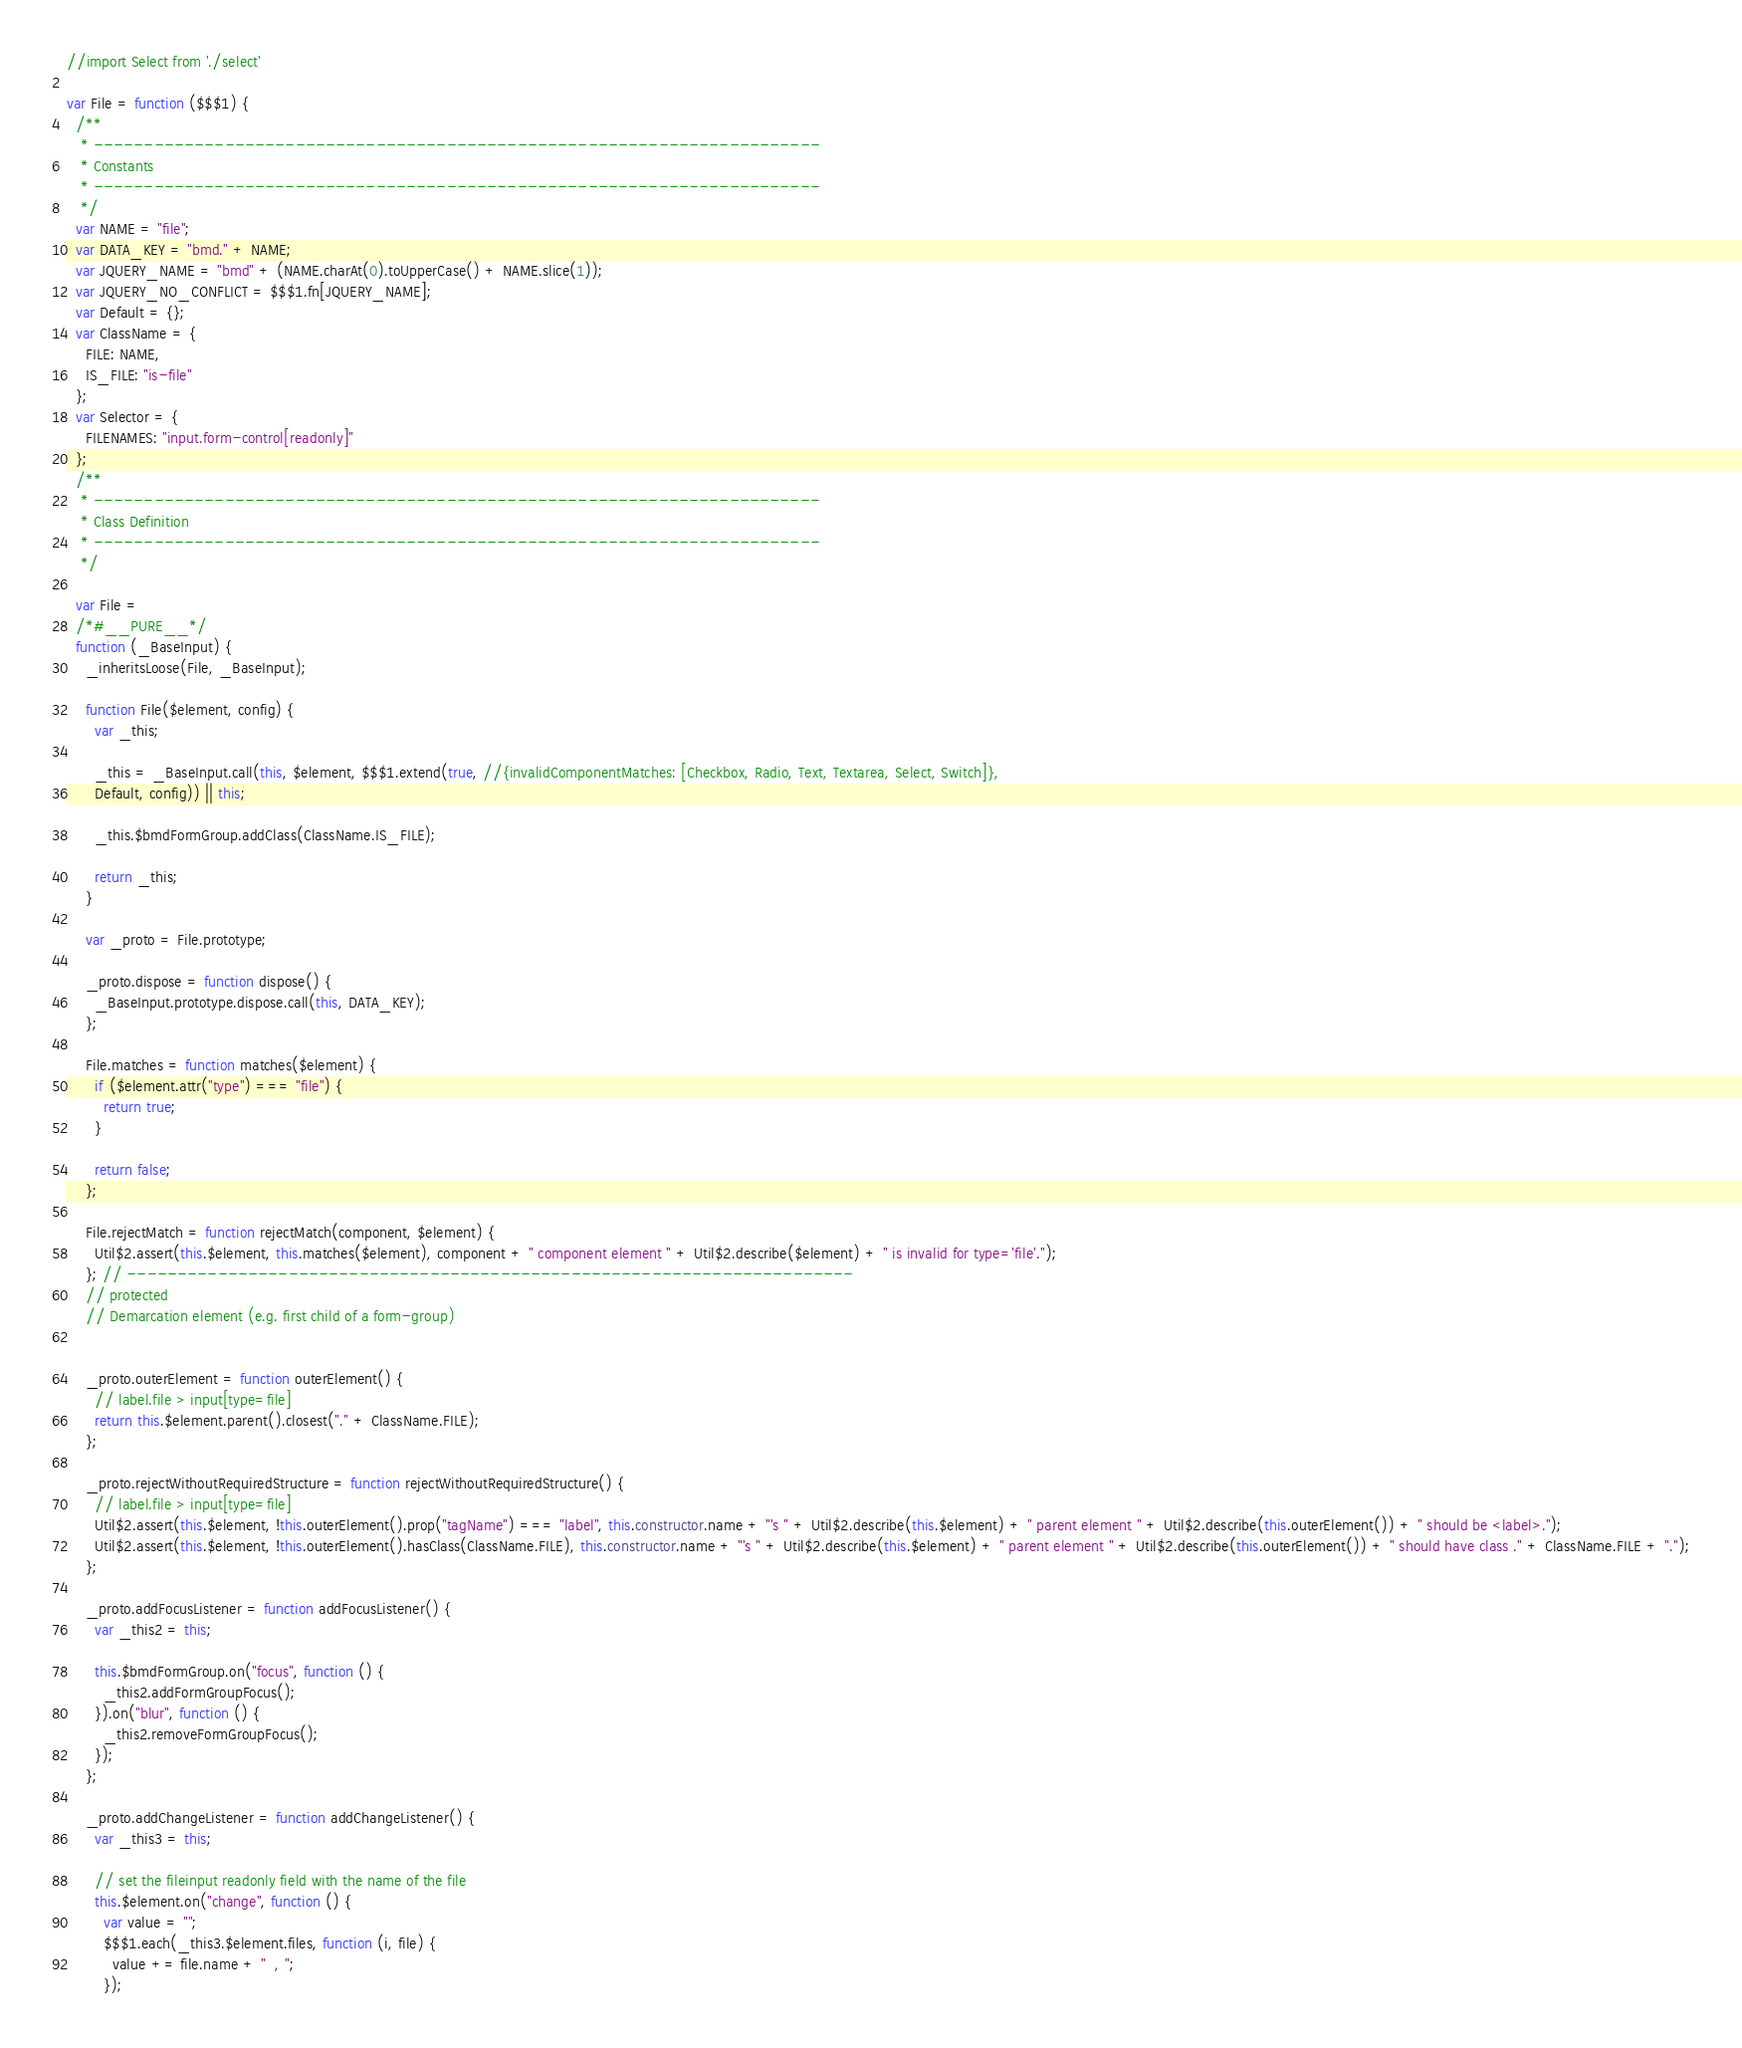<code> <loc_0><loc_0><loc_500><loc_500><_JavaScript_>//import Select from './select'

var File = function ($$$1) {
  /**
   * ------------------------------------------------------------------------
   * Constants
   * ------------------------------------------------------------------------
   */
  var NAME = "file";
  var DATA_KEY = "bmd." + NAME;
  var JQUERY_NAME = "bmd" + (NAME.charAt(0).toUpperCase() + NAME.slice(1));
  var JQUERY_NO_CONFLICT = $$$1.fn[JQUERY_NAME];
  var Default = {};
  var ClassName = {
    FILE: NAME,
    IS_FILE: "is-file"
  };
  var Selector = {
    FILENAMES: "input.form-control[readonly]"
  };
  /**
   * ------------------------------------------------------------------------
   * Class Definition
   * ------------------------------------------------------------------------
   */

  var File =
  /*#__PURE__*/
  function (_BaseInput) {
    _inheritsLoose(File, _BaseInput);

    function File($element, config) {
      var _this;

      _this = _BaseInput.call(this, $element, $$$1.extend(true, //{invalidComponentMatches: [Checkbox, Radio, Text, Textarea, Select, Switch]},
      Default, config)) || this;

      _this.$bmdFormGroup.addClass(ClassName.IS_FILE);

      return _this;
    }

    var _proto = File.prototype;

    _proto.dispose = function dispose() {
      _BaseInput.prototype.dispose.call(this, DATA_KEY);
    };

    File.matches = function matches($element) {
      if ($element.attr("type") === "file") {
        return true;
      }

      return false;
    };

    File.rejectMatch = function rejectMatch(component, $element) {
      Util$2.assert(this.$element, this.matches($element), component + " component element " + Util$2.describe($element) + " is invalid for type='file'.");
    }; // ------------------------------------------------------------------------
    // protected
    // Demarcation element (e.g. first child of a form-group)


    _proto.outerElement = function outerElement() {
      // label.file > input[type=file]
      return this.$element.parent().closest("." + ClassName.FILE);
    };

    _proto.rejectWithoutRequiredStructure = function rejectWithoutRequiredStructure() {
      // label.file > input[type=file]
      Util$2.assert(this.$element, !this.outerElement().prop("tagName") === "label", this.constructor.name + "'s " + Util$2.describe(this.$element) + " parent element " + Util$2.describe(this.outerElement()) + " should be <label>.");
      Util$2.assert(this.$element, !this.outerElement().hasClass(ClassName.FILE), this.constructor.name + "'s " + Util$2.describe(this.$element) + " parent element " + Util$2.describe(this.outerElement()) + " should have class ." + ClassName.FILE + ".");
    };

    _proto.addFocusListener = function addFocusListener() {
      var _this2 = this;

      this.$bmdFormGroup.on("focus", function () {
        _this2.addFormGroupFocus();
      }).on("blur", function () {
        _this2.removeFormGroupFocus();
      });
    };

    _proto.addChangeListener = function addChangeListener() {
      var _this3 = this;

      // set the fileinput readonly field with the name of the file
      this.$element.on("change", function () {
        var value = "";
        $$$1.each(_this3.$element.files, function (i, file) {
          value += file.name + "  , ";
        });</code> 